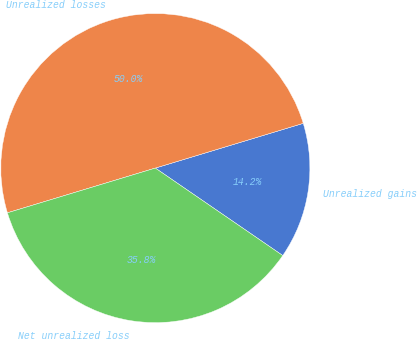Convert chart. <chart><loc_0><loc_0><loc_500><loc_500><pie_chart><fcel>Unrealized gains<fcel>Unrealized losses<fcel>Net unrealized loss<nl><fcel>14.25%<fcel>50.0%<fcel>35.75%<nl></chart> 